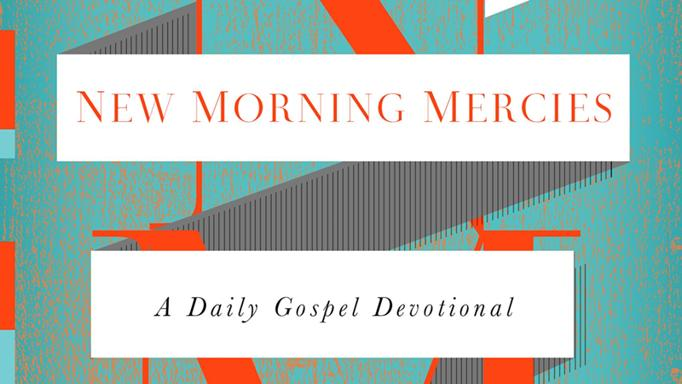What colors are seen in the banner? The banner prominently features white and orange colors, forming a striking contrast. Besides these, the geometric background includes a grayish stripe that adds depth to the design, enhancing the overall visual impact. 